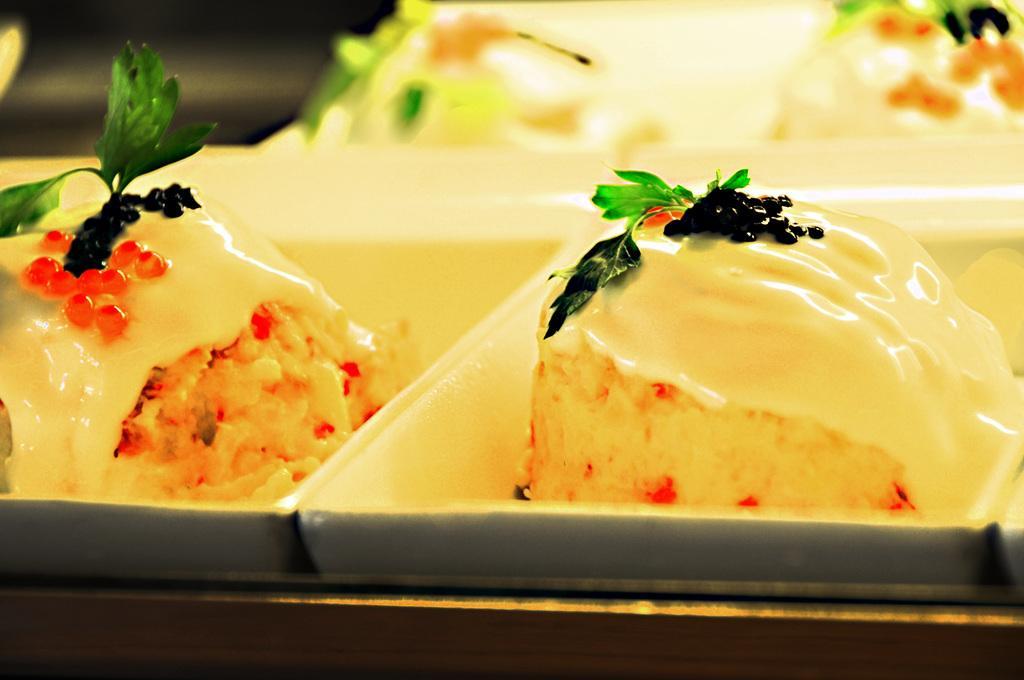Please provide a concise description of this image. In this image I can see food items placed on a tray. These food items are garnished with the leaves. The background is blurred. 